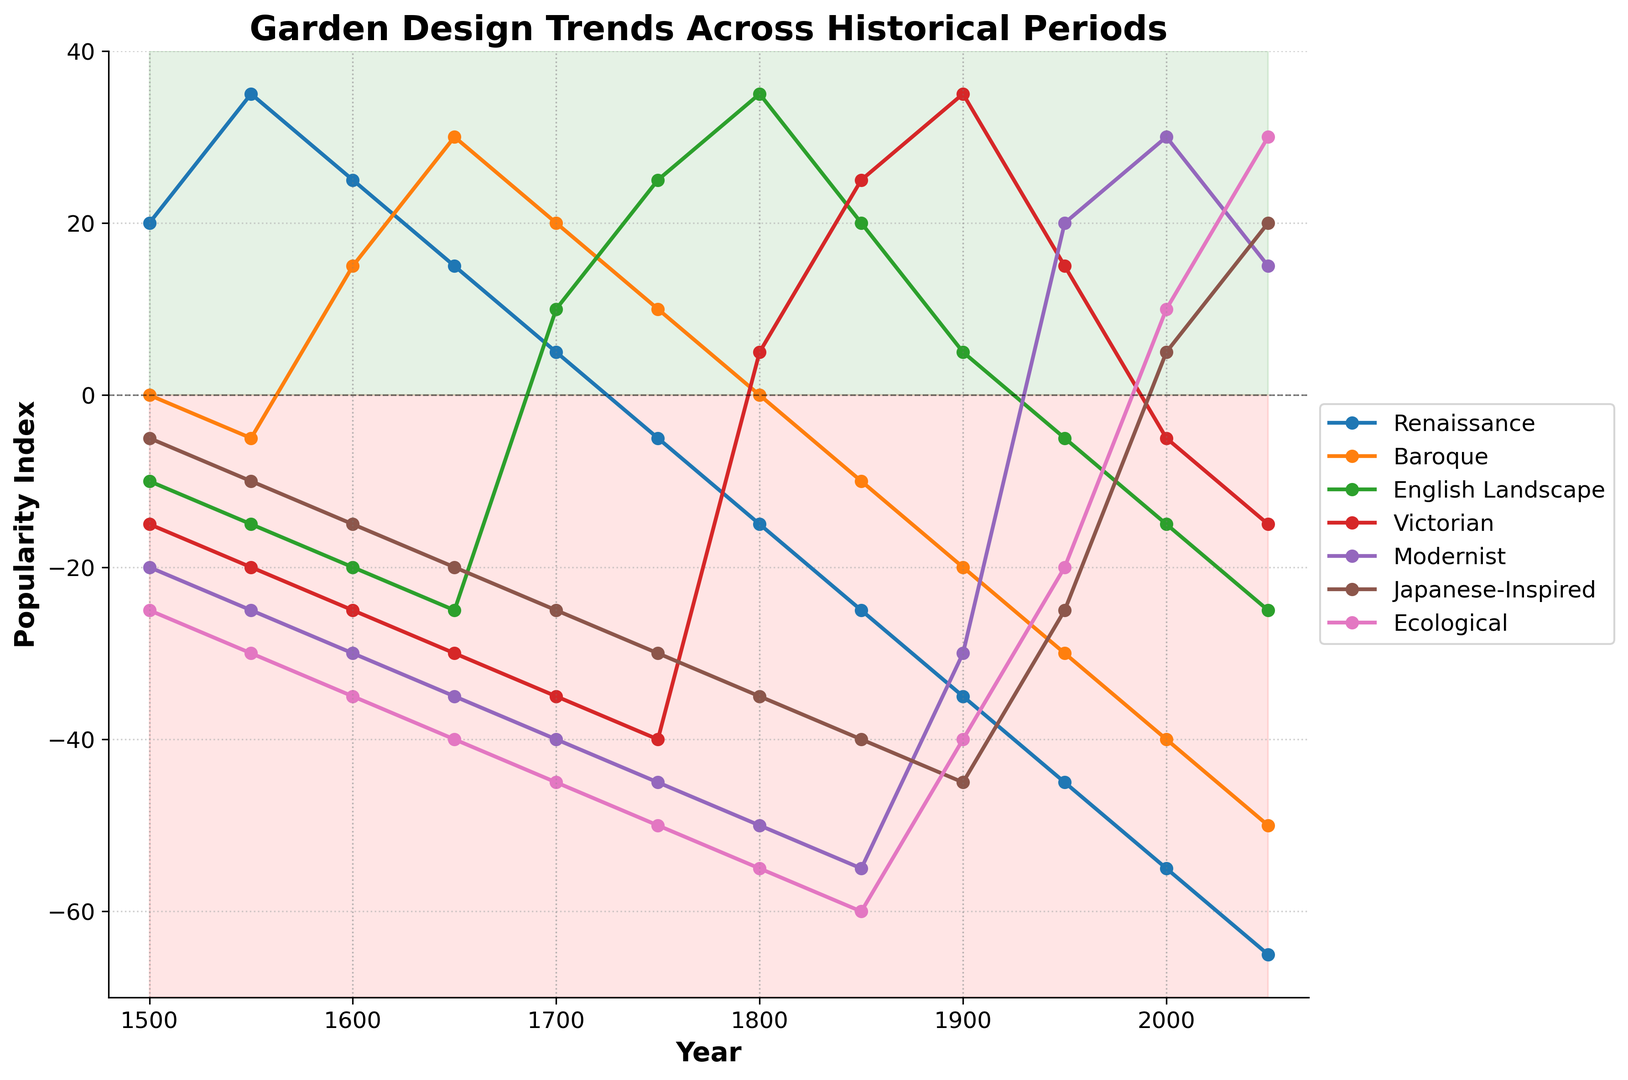What historical period saw the highest popularity for the Renaissance garden style? The Renaissance garden style reached its highest popularity in the middle of a spike around the year 1550. Observing from the plot, this is when the value of the Renaissance style was at 35, which is the highest point on the chart for that style.
Answer: 1550 Between which years did the Baroque garden style peak in popularity? The Baroque garden style reached its peak popularity twice around 1650 and 1600. The highest points in the plot for Baroque are at these years with values reaching 30 and 15 respectively.
Answer: 1650 and 1600 Which garden style shows a steady increase in popularity after 1900? Observing the plot, the Modernist garden style shows a steady increase in popularity after 1900, with its values rising from -30 in 1900 to 30 in 2000 and then slightly decreasing to 15 by 2050.
Answer: Modernist How do the trends of the English Landscape and Victorian styles compare between 1800 and 1950? Between 1800 and 1950, the English Landscape style shows an initial decline followed by a rise, whereas the Victorian style shows a rise. English Landscape starts at 35 in 1800, dips to 5 by 1900, and then rises again slightly. The Victorian style starts at 5 in 1800 and then rises steadily to peak at 35 in 1900 before stabilizing again.
Answer: English Landscape: decline then rise; Victorian: steady rise What was the lowest point of the Japanese-Inspired garden style and when did it occur? The lowest point for the Japanese-Inspired garden style is clearly observed in the plot around the year 1800 where it reaches -35. The trend line starts declining from previous points and the minimum value is reached at this year.
Answer: 1800 and -35 What is the difference in popularity between the Renaissance and Modernist styles in 2000? To find the difference in popularity between these two styles in 2000, identify their values: the Renaissance is at -55 and Modernist is at 30. Subtracting these, the difference is 30 - (-55) = 85.
Answer: 85 In which period did the Ecological garden style experience an increase in popularity? The Ecological garden style shows an increase in popularity after 1950. From being at -20 in 1950, the trend rises to 10 in 2000 and further increases to 30 by 2050.
Answer: After 1950 Which garden style remained mostly negative throughout the entire timeline? Observing the entire plot, the Ecological garden style remains mostly negative throughout the timeline, always staying below the zero line and being prominent in the reddish region of the chart.
Answer: Ecological Comparing 1500 and 1600, which garden style shows the greatest increase in popularity? The greatest increase over this period is seen in the Baroque style, which goes from 0 in 1500 to 15 in 1600. This is observed as the highest positive trend increase among the styles between these years.
Answer: Baroque 